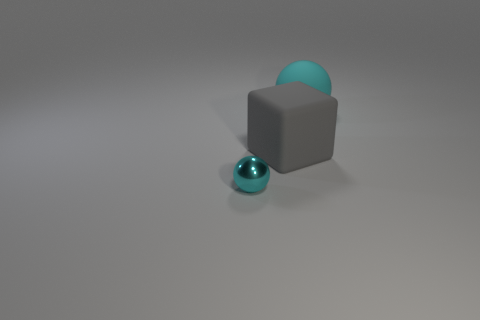Add 2 cyan balls. How many objects exist? 5 Subtract 0 cyan cylinders. How many objects are left? 3 Subtract all balls. How many objects are left? 1 Subtract all gray spheres. Subtract all gray cylinders. How many spheres are left? 2 Subtract all large red spheres. Subtract all gray cubes. How many objects are left? 2 Add 1 tiny cyan metal objects. How many tiny cyan metal objects are left? 2 Add 3 small cyan objects. How many small cyan objects exist? 4 